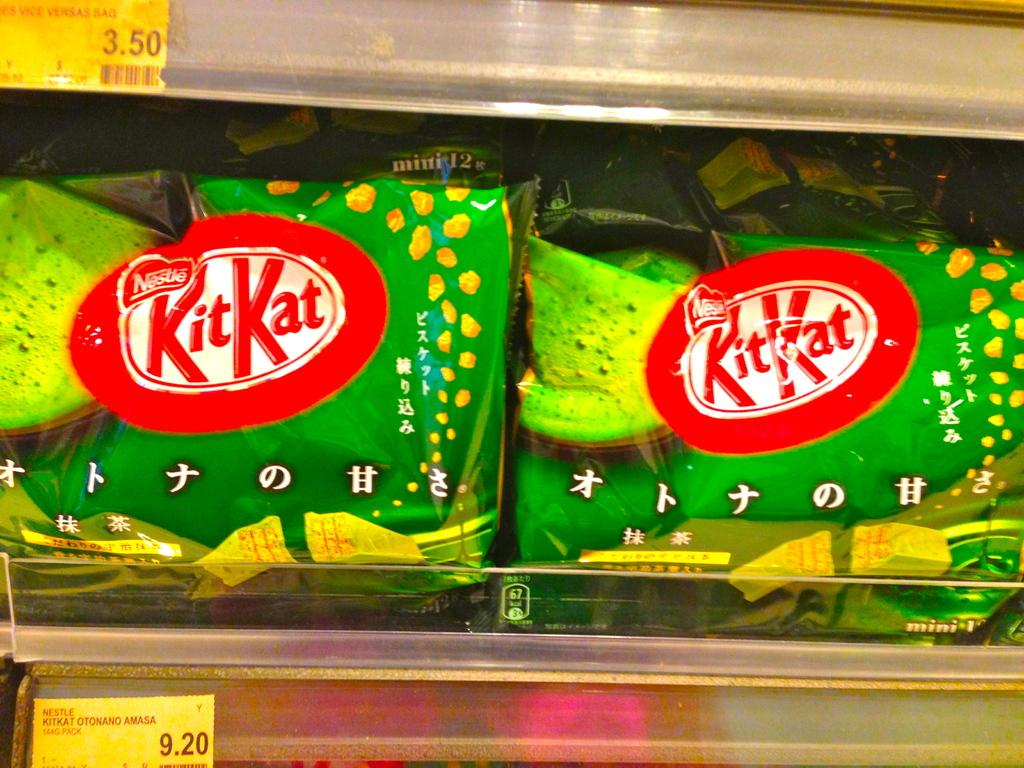What is visible on the rack in the image? There are packets of food products on a rack in the image. Are there any additional items on the rack? Yes, there are two small pieces of paper on the rack. What can be found on the pieces of paper? There is text on the papers. How much money is being wished for on the arch in the image? There is no arch or mention of money or wishing in the image. 